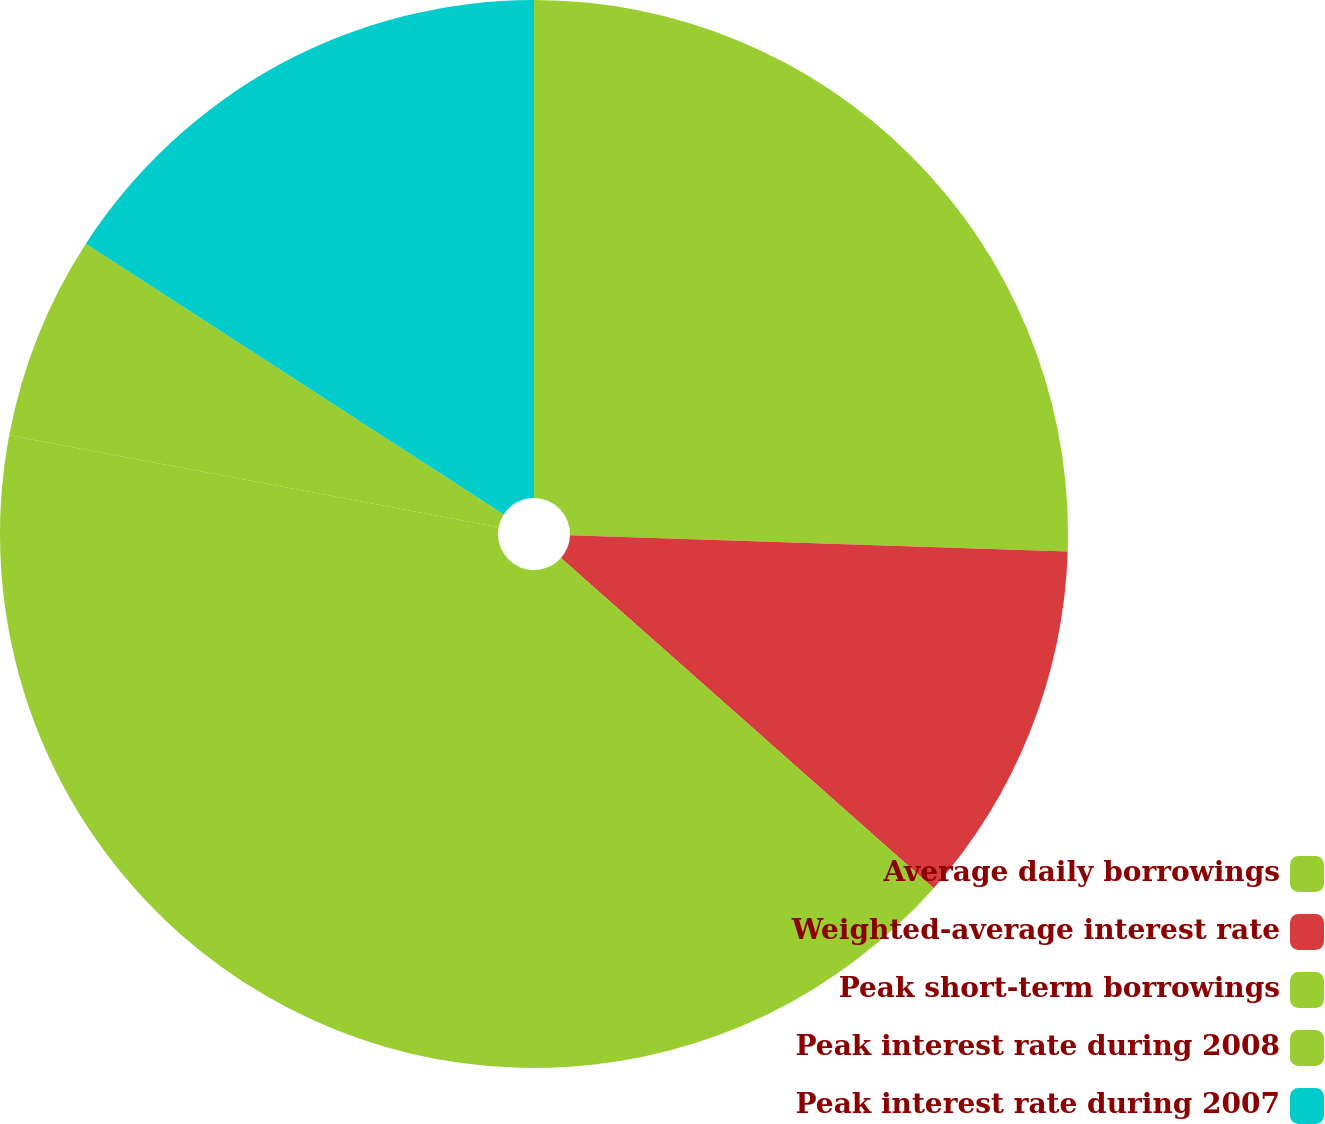<chart> <loc_0><loc_0><loc_500><loc_500><pie_chart><fcel>Average daily borrowings<fcel>Weighted-average interest rate<fcel>Peak short-term borrowings<fcel>Peak interest rate during 2008<fcel>Peak interest rate during 2007<nl><fcel>25.52%<fcel>11.02%<fcel>41.42%<fcel>6.19%<fcel>15.85%<nl></chart> 